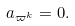Convert formula to latex. <formula><loc_0><loc_0><loc_500><loc_500>a _ { \varpi ^ { k } } = 0 .</formula> 